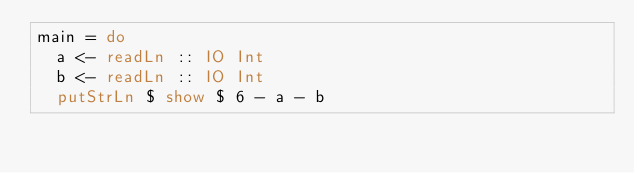Convert code to text. <code><loc_0><loc_0><loc_500><loc_500><_Haskell_>main = do
  a <- readLn :: IO Int
  b <- readLn :: IO Int
  putStrLn $ show $ 6 - a - b
</code> 